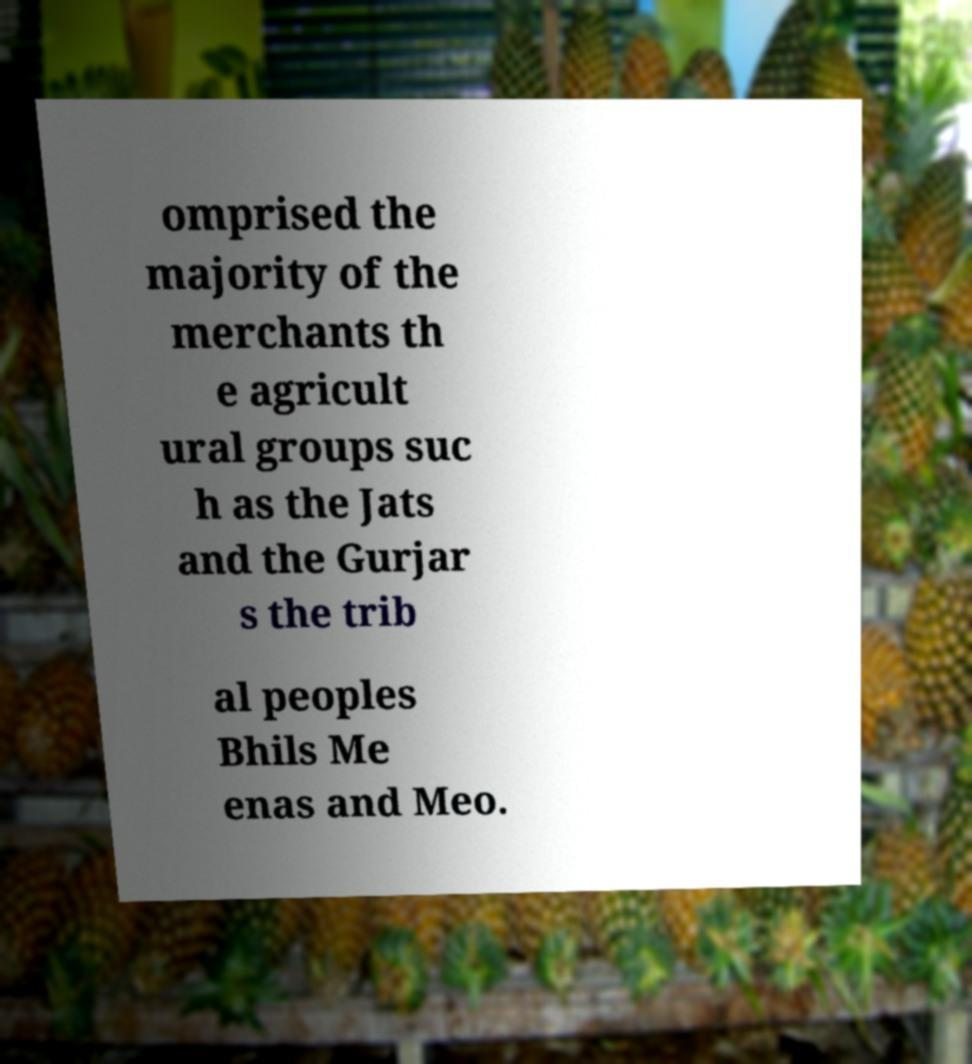Please identify and transcribe the text found in this image. omprised the majority of the merchants th e agricult ural groups suc h as the Jats and the Gurjar s the trib al peoples Bhils Me enas and Meo. 